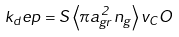<formula> <loc_0><loc_0><loc_500><loc_500>k _ { d } e p = S \left < \pi a _ { g r } ^ { 2 } n _ { g } \right > v _ { C } O</formula> 